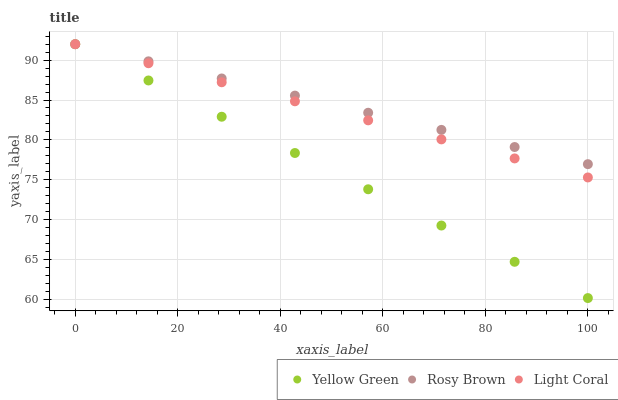Does Yellow Green have the minimum area under the curve?
Answer yes or no. Yes. Does Rosy Brown have the maximum area under the curve?
Answer yes or no. Yes. Does Rosy Brown have the minimum area under the curve?
Answer yes or no. No. Does Yellow Green have the maximum area under the curve?
Answer yes or no. No. Is Light Coral the smoothest?
Answer yes or no. Yes. Is Rosy Brown the roughest?
Answer yes or no. Yes. Is Yellow Green the smoothest?
Answer yes or no. No. Is Yellow Green the roughest?
Answer yes or no. No. Does Yellow Green have the lowest value?
Answer yes or no. Yes. Does Rosy Brown have the lowest value?
Answer yes or no. No. Does Yellow Green have the highest value?
Answer yes or no. Yes. Does Light Coral intersect Yellow Green?
Answer yes or no. Yes. Is Light Coral less than Yellow Green?
Answer yes or no. No. Is Light Coral greater than Yellow Green?
Answer yes or no. No. 